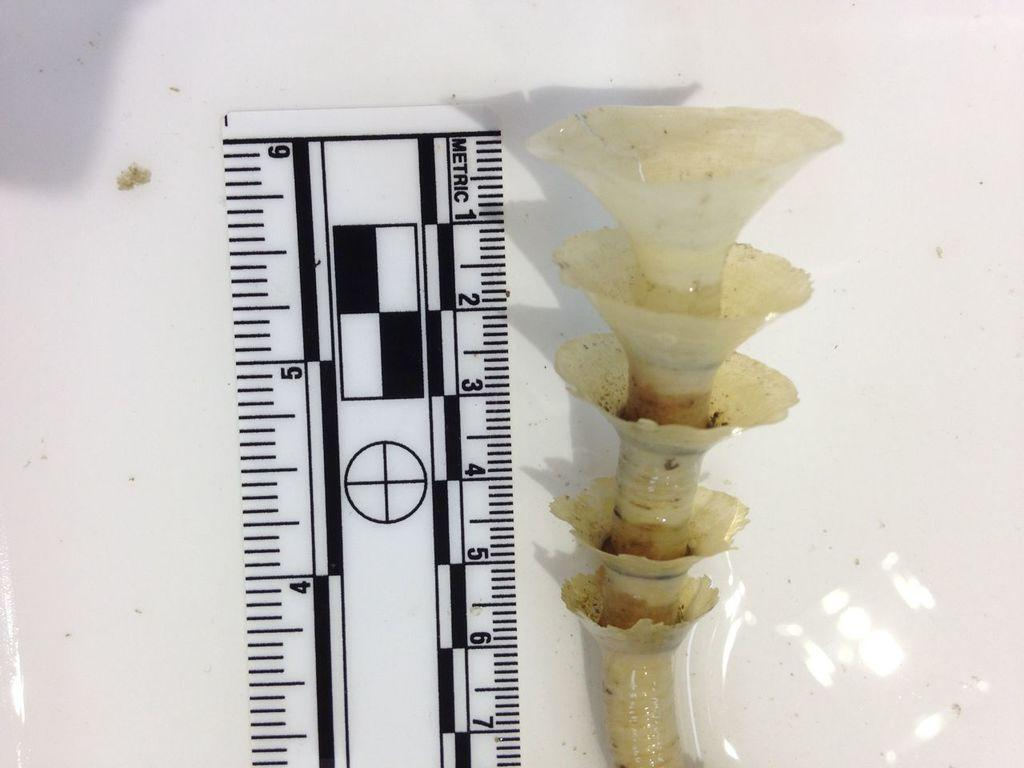<image>
Present a compact description of the photo's key features. A plant appears to be at least 6 inches tall. 